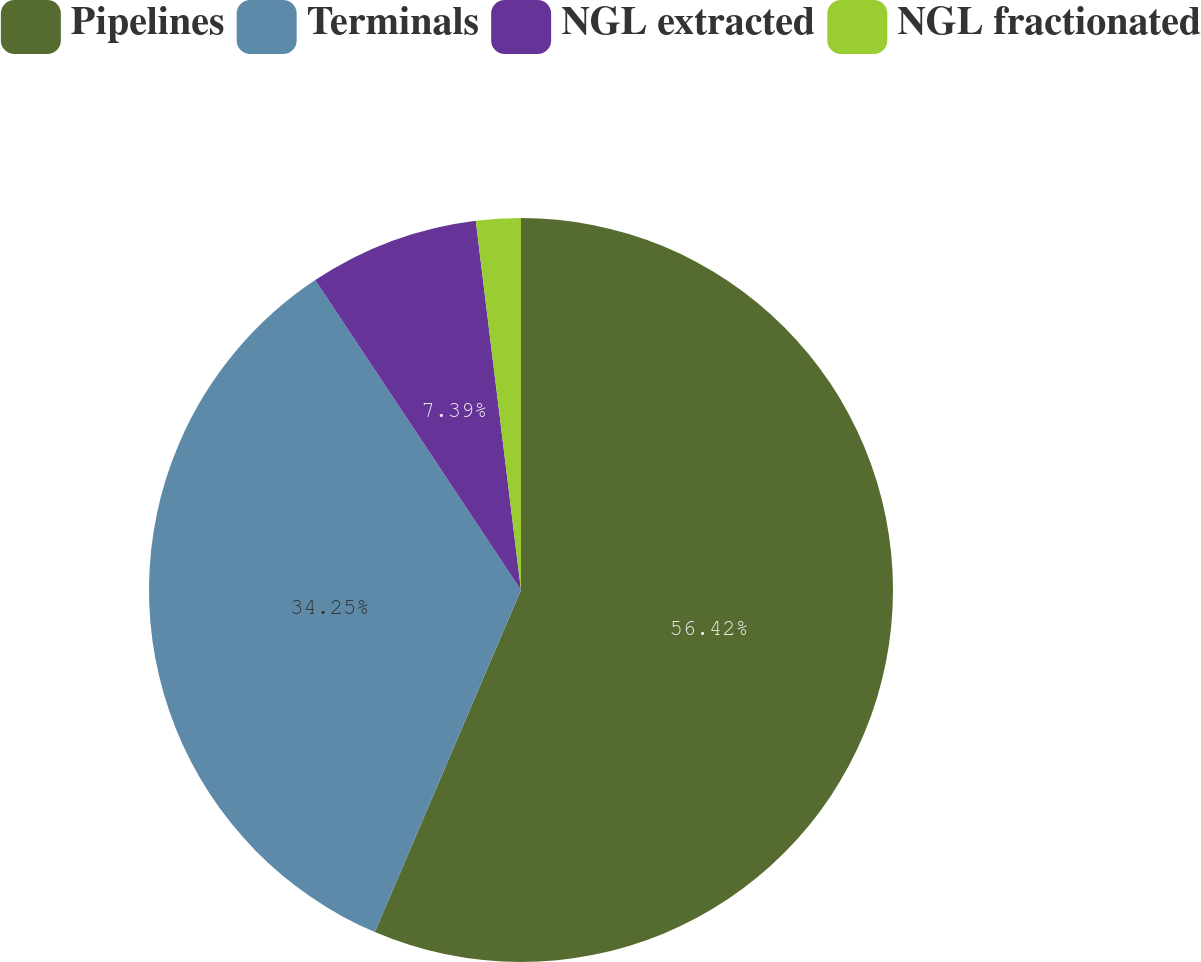Convert chart. <chart><loc_0><loc_0><loc_500><loc_500><pie_chart><fcel>Pipelines<fcel>Terminals<fcel>NGL extracted<fcel>NGL fractionated<nl><fcel>56.43%<fcel>34.25%<fcel>7.39%<fcel>1.94%<nl></chart> 